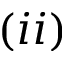<formula> <loc_0><loc_0><loc_500><loc_500>( i i )</formula> 